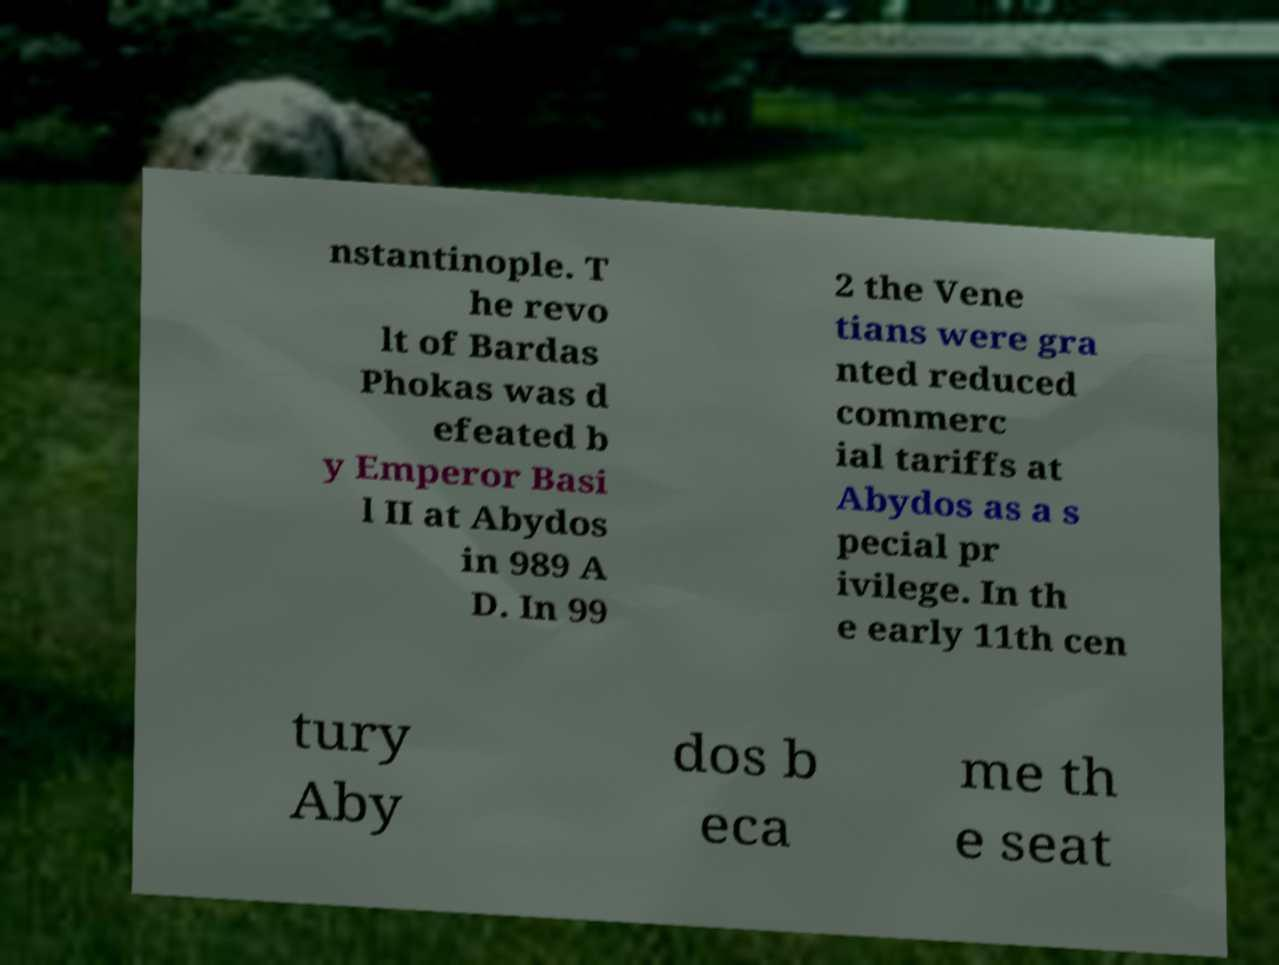I need the written content from this picture converted into text. Can you do that? nstantinople. T he revo lt of Bardas Phokas was d efeated b y Emperor Basi l II at Abydos in 989 A D. In 99 2 the Vene tians were gra nted reduced commerc ial tariffs at Abydos as a s pecial pr ivilege. In th e early 11th cen tury Aby dos b eca me th e seat 